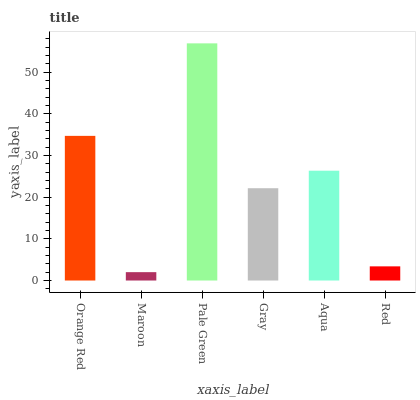Is Maroon the minimum?
Answer yes or no. Yes. Is Pale Green the maximum?
Answer yes or no. Yes. Is Pale Green the minimum?
Answer yes or no. No. Is Maroon the maximum?
Answer yes or no. No. Is Pale Green greater than Maroon?
Answer yes or no. Yes. Is Maroon less than Pale Green?
Answer yes or no. Yes. Is Maroon greater than Pale Green?
Answer yes or no. No. Is Pale Green less than Maroon?
Answer yes or no. No. Is Aqua the high median?
Answer yes or no. Yes. Is Gray the low median?
Answer yes or no. Yes. Is Gray the high median?
Answer yes or no. No. Is Pale Green the low median?
Answer yes or no. No. 